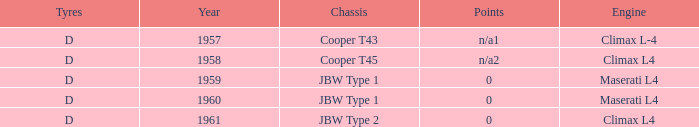What engine was for the vehicle with a cooper t43 chassis? Climax L-4. 